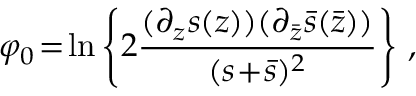Convert formula to latex. <formula><loc_0><loc_0><loc_500><loc_500>\varphi _ { 0 } \, = \, \ln \left \{ 2 \frac { ( \partial _ { z } s ( z ) ) ( \partial _ { \bar { z } } \bar { s } ( \bar { z } ) ) } { ( s \, + \, \bar { s } ) ^ { 2 } } \right \} \, ,</formula> 